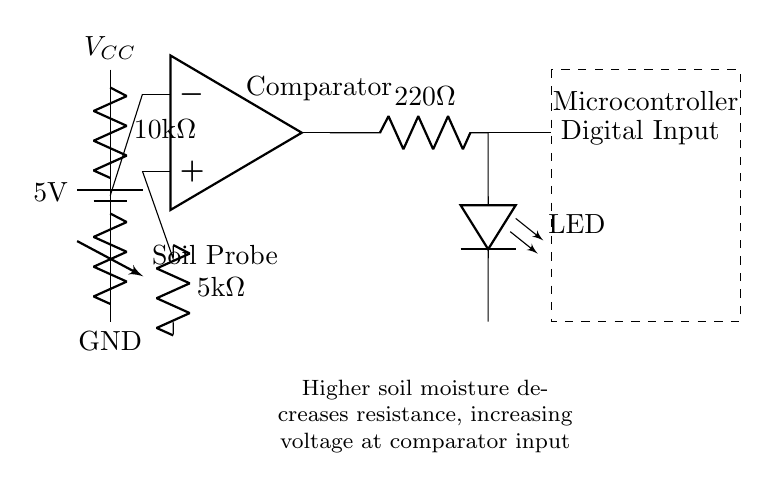What is the voltage of the battery in this circuit? The voltage of the battery is 5 volts, as indicated on the circuit diagram with the label for the battery source.
Answer: 5 volts What type of resistor is used as the soil probe? The soil probe is represented as a variable resistor, which adjusts its resistance based on soil moisture content.
Answer: Variable resistor How many ohms is the second resistor connected to the comparator? The resistor connected to the comparator is labeled as 5 kilo ohms. The 'k' indicates that it is in thousands, making it 5000 ohms.
Answer: 5 kilo ohms What happens to the voltage at the comparator input when soil moisture increases? The voltage at the comparator input increases because higher soil moisture decreases the resistance of the soil probe, causing more voltage to be supplied to the comparator.
Answer: Increases What is the purpose of the led in this circuit? The LED indicates the output state of the comparator; it lights up when the comparator's output is high, signaling that the soil moisture is below the threshold.
Answer: Indicate moisture level What component acts as the decision-maker in this circuit? The component that acts as the decision-maker is the comparator, which compares the voltages to determine if the soil moisture is within an acceptable range.
Answer: Comparator How is the microcontroller connected in this circuit? The microcontroller is connected to the output of the comparator via a digital input, allowing it to read the moisture level indicated by the comparator's output.
Answer: Via digital input 